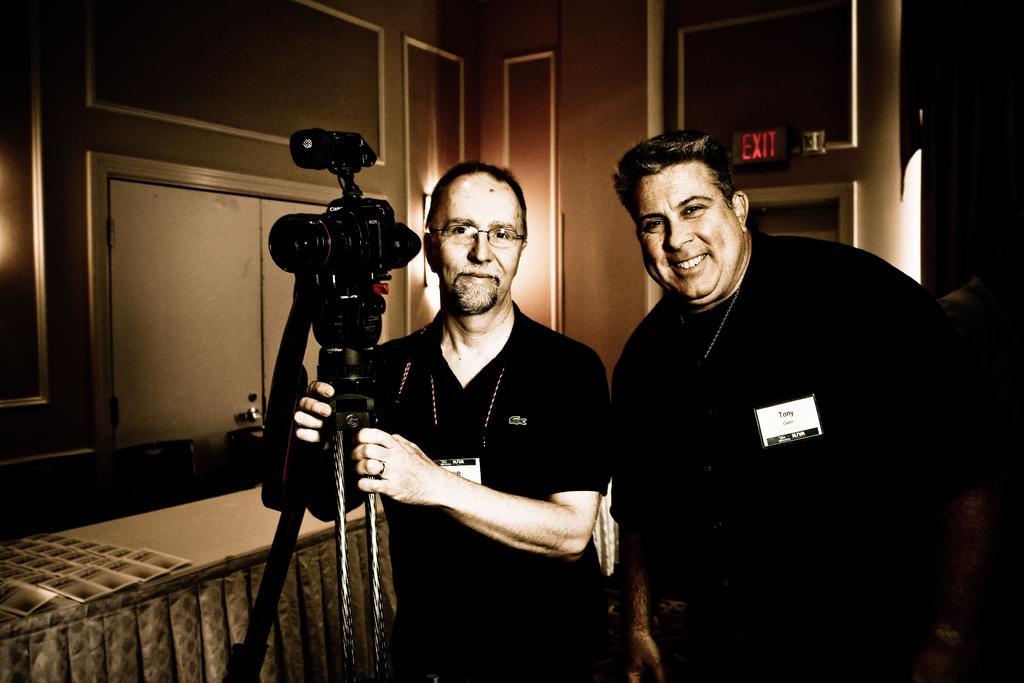How would you summarize this image in a sentence or two? In this picture I can see a man holding the camera in the middle, on the right side there is another man, he is smiling, in the background there is an exit board. 